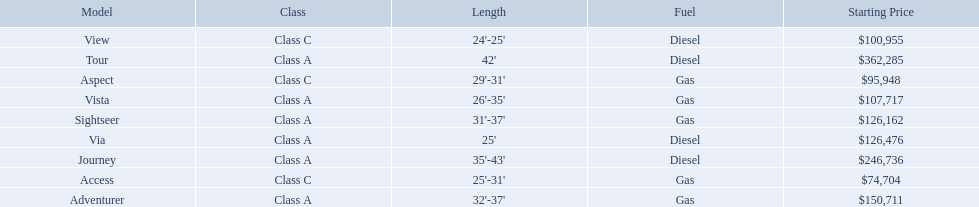What are all of the winnebago models? Tour, Journey, Adventurer, Via, Sightseer, Vista, View, Aspect, Access. What are their prices? $362,285, $246,736, $150,711, $126,476, $126,162, $107,717, $100,955, $95,948, $74,704. And which model costs the most? Tour. 